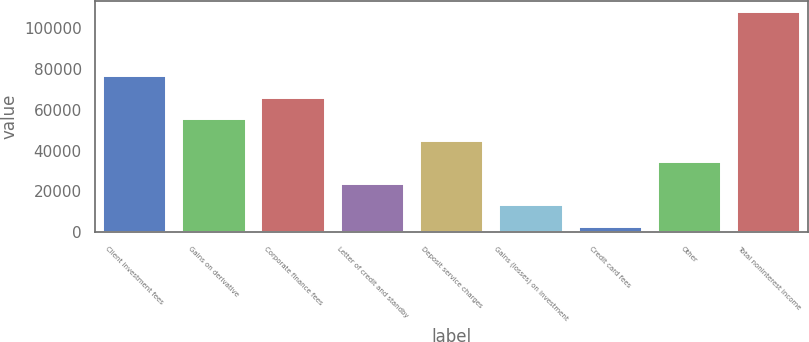Convert chart. <chart><loc_0><loc_0><loc_500><loc_500><bar_chart><fcel>Client investment fees<fcel>Gains on derivative<fcel>Corporate finance fees<fcel>Letter of credit and standby<fcel>Deposit service charges<fcel>Gains (losses) on investment<fcel>Credit card fees<fcel>Other<fcel>Total noninterest income<nl><fcel>76286.9<fcel>55295.5<fcel>65791.2<fcel>23808.4<fcel>44799.8<fcel>13312.7<fcel>2817<fcel>34304.1<fcel>107774<nl></chart> 